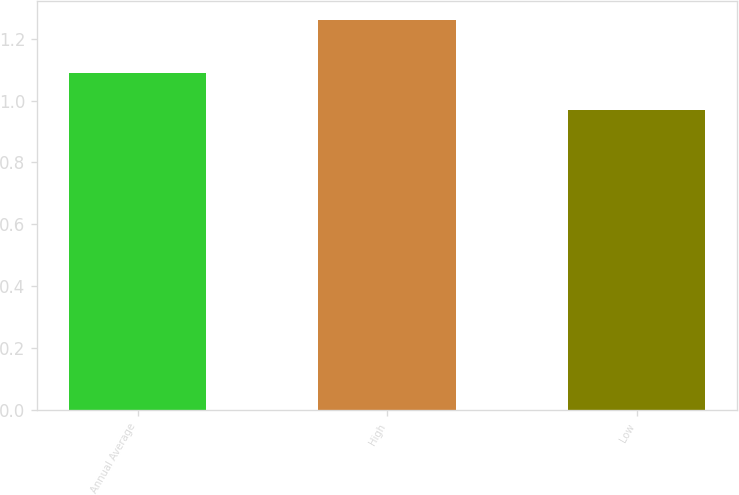<chart> <loc_0><loc_0><loc_500><loc_500><bar_chart><fcel>Annual Average<fcel>High<fcel>Low<nl><fcel>1.09<fcel>1.26<fcel>0.97<nl></chart> 